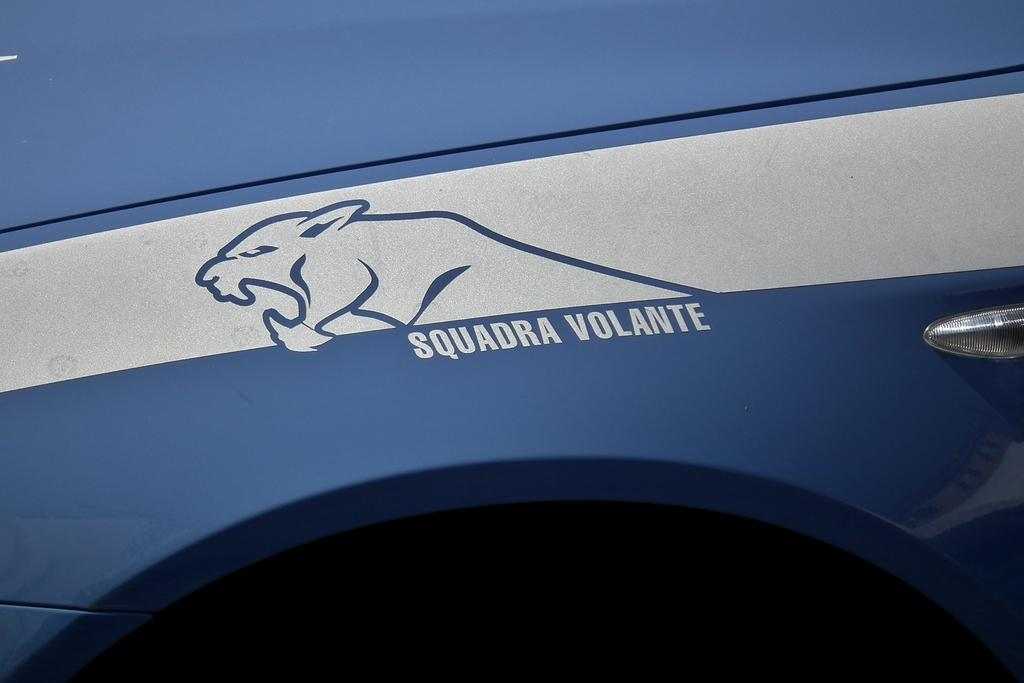What is the color of the vehicle in the image? The vehicle has a blue color. What type of design or image is on the vehicle? There is a drawing of a jaguar on the vehicle. What time does the clock on the vehicle show in the image? There is no clock present on the vehicle in the image. 